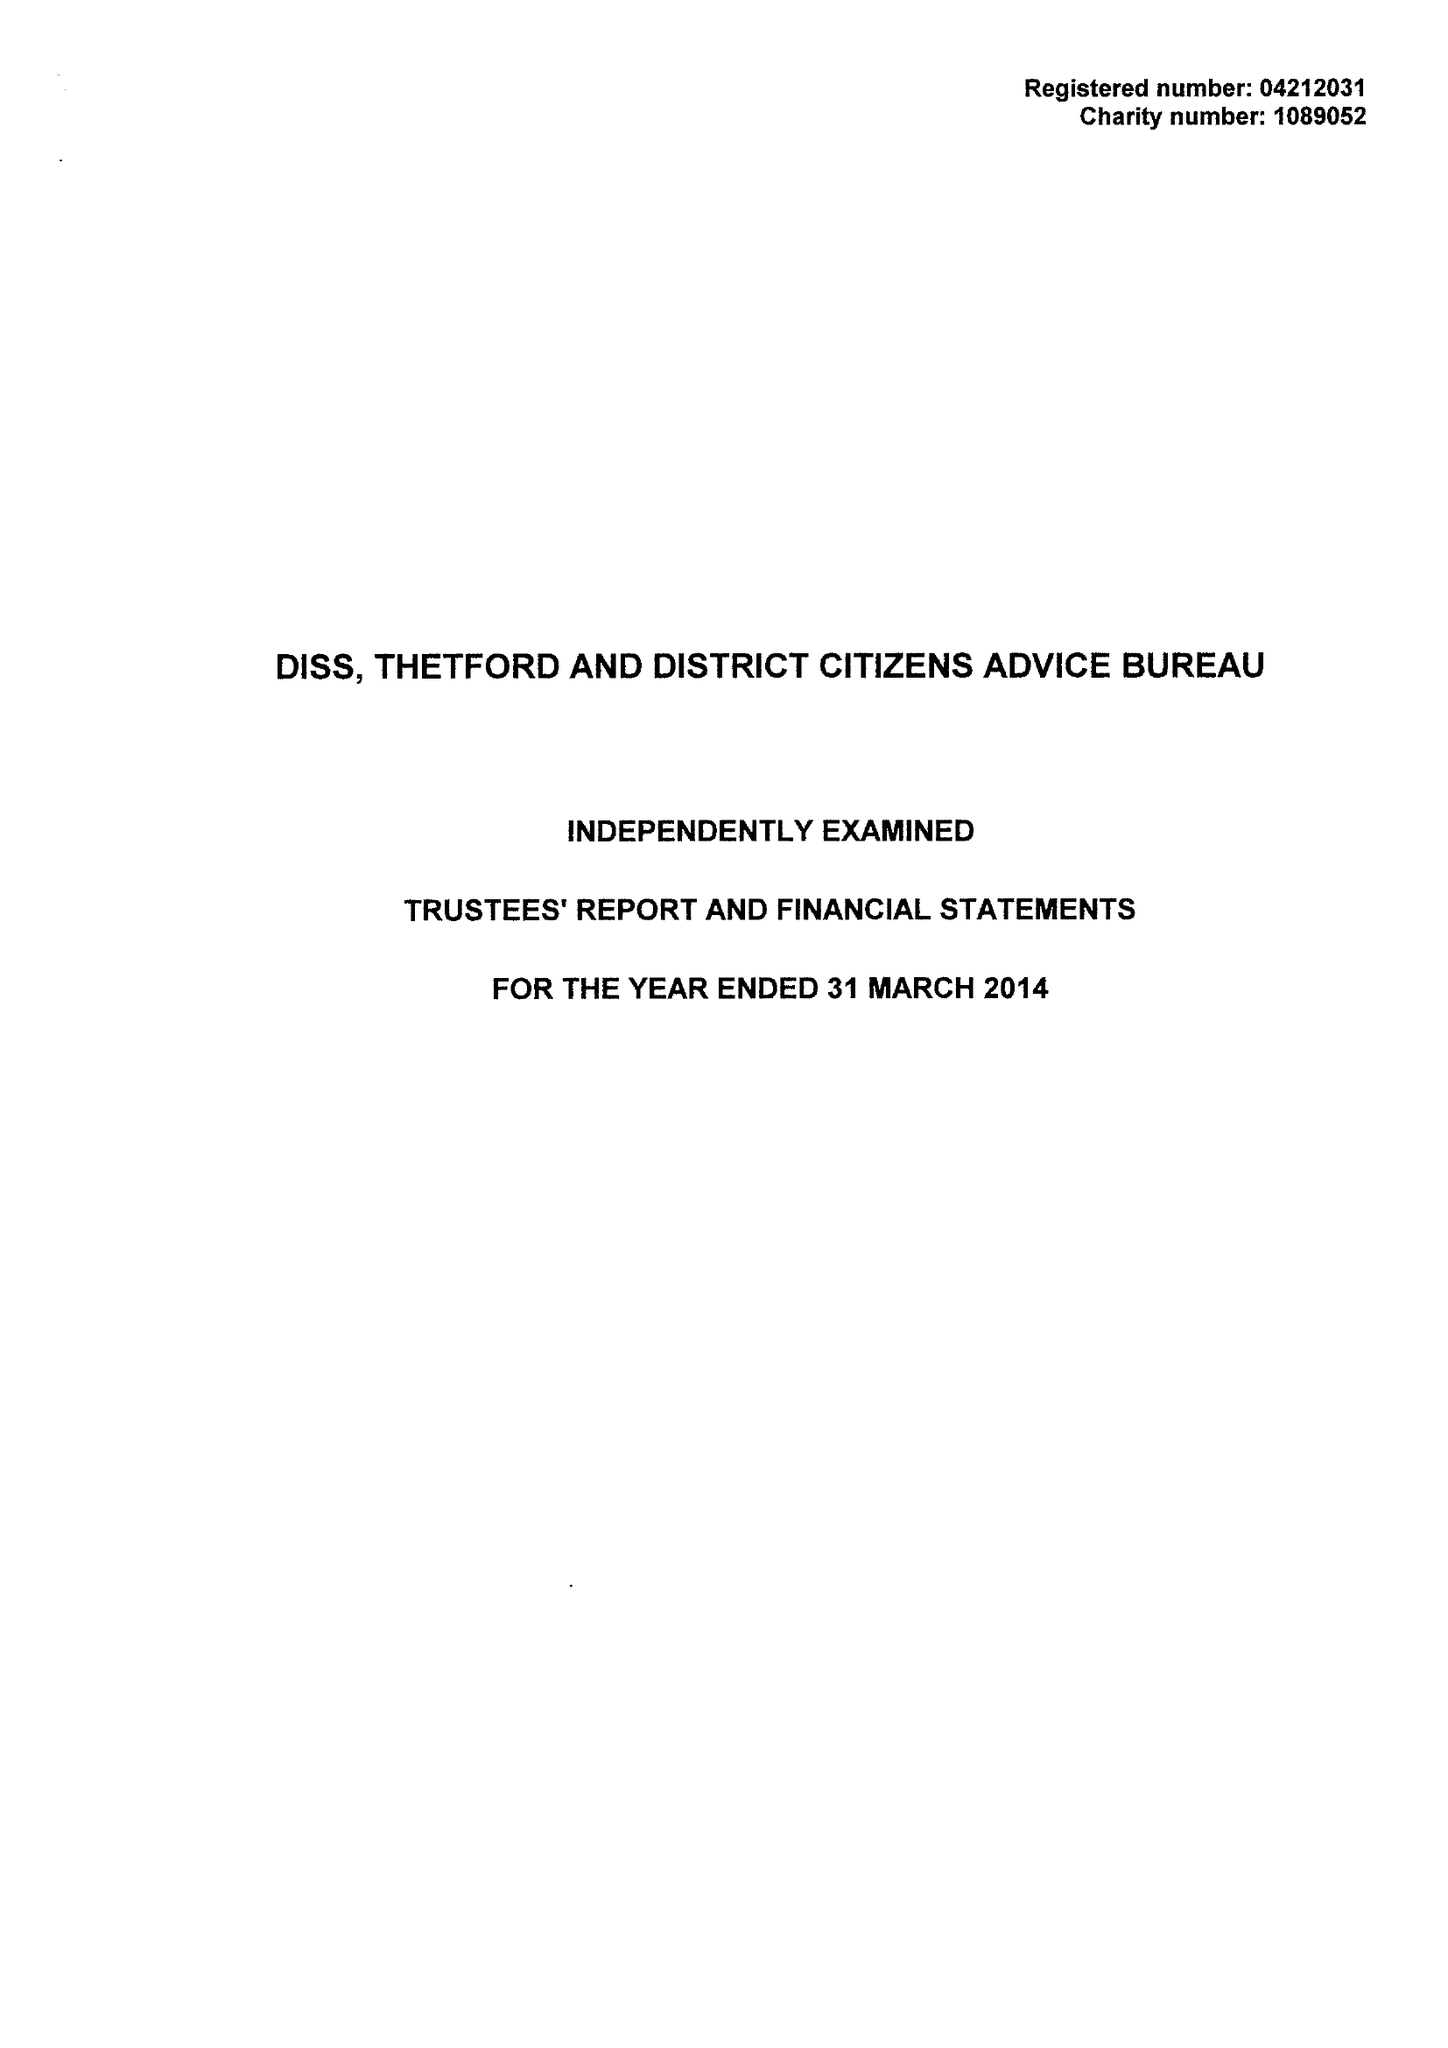What is the value for the income_annually_in_british_pounds?
Answer the question using a single word or phrase. 307358.00 